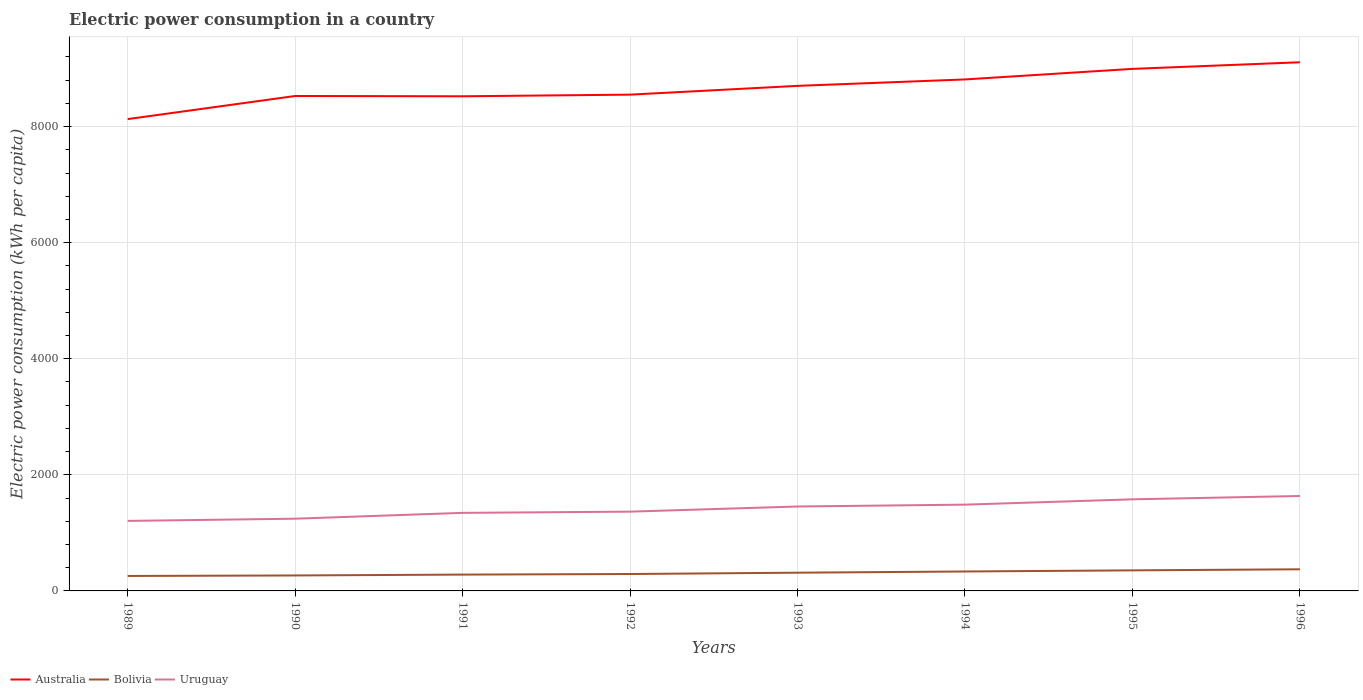How many different coloured lines are there?
Give a very brief answer. 3. Is the number of lines equal to the number of legend labels?
Offer a very short reply. Yes. Across all years, what is the maximum electric power consumption in in Bolivia?
Offer a very short reply. 257.77. In which year was the electric power consumption in in Uruguay maximum?
Offer a very short reply. 1989. What is the total electric power consumption in in Uruguay in the graph?
Your answer should be compact. -391.38. What is the difference between the highest and the second highest electric power consumption in in Bolivia?
Provide a succinct answer. 115.02. What is the difference between the highest and the lowest electric power consumption in in Bolivia?
Provide a succinct answer. 4. How many lines are there?
Your response must be concise. 3. Are the values on the major ticks of Y-axis written in scientific E-notation?
Provide a short and direct response. No. Does the graph contain any zero values?
Offer a very short reply. No. Does the graph contain grids?
Keep it short and to the point. Yes. Where does the legend appear in the graph?
Your answer should be very brief. Bottom left. How many legend labels are there?
Offer a very short reply. 3. How are the legend labels stacked?
Ensure brevity in your answer.  Horizontal. What is the title of the graph?
Your answer should be very brief. Electric power consumption in a country. What is the label or title of the X-axis?
Offer a terse response. Years. What is the label or title of the Y-axis?
Give a very brief answer. Electric power consumption (kWh per capita). What is the Electric power consumption (kWh per capita) in Australia in 1989?
Your answer should be very brief. 8129.1. What is the Electric power consumption (kWh per capita) in Bolivia in 1989?
Offer a terse response. 257.77. What is the Electric power consumption (kWh per capita) in Uruguay in 1989?
Your answer should be compact. 1206.22. What is the Electric power consumption (kWh per capita) of Australia in 1990?
Offer a terse response. 8527.23. What is the Electric power consumption (kWh per capita) of Bolivia in 1990?
Give a very brief answer. 266.47. What is the Electric power consumption (kWh per capita) in Uruguay in 1990?
Your response must be concise. 1244.38. What is the Electric power consumption (kWh per capita) of Australia in 1991?
Your response must be concise. 8522.16. What is the Electric power consumption (kWh per capita) in Bolivia in 1991?
Offer a very short reply. 281.3. What is the Electric power consumption (kWh per capita) in Uruguay in 1991?
Provide a short and direct response. 1344.81. What is the Electric power consumption (kWh per capita) of Australia in 1992?
Ensure brevity in your answer.  8550.33. What is the Electric power consumption (kWh per capita) in Bolivia in 1992?
Offer a terse response. 291.23. What is the Electric power consumption (kWh per capita) in Uruguay in 1992?
Give a very brief answer. 1365.83. What is the Electric power consumption (kWh per capita) in Australia in 1993?
Offer a very short reply. 8701.76. What is the Electric power consumption (kWh per capita) of Bolivia in 1993?
Provide a succinct answer. 314.28. What is the Electric power consumption (kWh per capita) in Uruguay in 1993?
Offer a terse response. 1454.62. What is the Electric power consumption (kWh per capita) of Australia in 1994?
Provide a succinct answer. 8812.49. What is the Electric power consumption (kWh per capita) in Bolivia in 1994?
Ensure brevity in your answer.  334.96. What is the Electric power consumption (kWh per capita) of Uruguay in 1994?
Offer a very short reply. 1486.44. What is the Electric power consumption (kWh per capita) of Australia in 1995?
Ensure brevity in your answer.  8994.36. What is the Electric power consumption (kWh per capita) of Bolivia in 1995?
Provide a succinct answer. 354.18. What is the Electric power consumption (kWh per capita) in Uruguay in 1995?
Offer a very short reply. 1578.08. What is the Electric power consumption (kWh per capita) of Australia in 1996?
Give a very brief answer. 9108.3. What is the Electric power consumption (kWh per capita) in Bolivia in 1996?
Keep it short and to the point. 372.79. What is the Electric power consumption (kWh per capita) in Uruguay in 1996?
Offer a very short reply. 1635.76. Across all years, what is the maximum Electric power consumption (kWh per capita) in Australia?
Provide a short and direct response. 9108.3. Across all years, what is the maximum Electric power consumption (kWh per capita) in Bolivia?
Offer a terse response. 372.79. Across all years, what is the maximum Electric power consumption (kWh per capita) in Uruguay?
Your answer should be compact. 1635.76. Across all years, what is the minimum Electric power consumption (kWh per capita) in Australia?
Offer a terse response. 8129.1. Across all years, what is the minimum Electric power consumption (kWh per capita) of Bolivia?
Your answer should be compact. 257.77. Across all years, what is the minimum Electric power consumption (kWh per capita) in Uruguay?
Your answer should be very brief. 1206.22. What is the total Electric power consumption (kWh per capita) of Australia in the graph?
Offer a very short reply. 6.93e+04. What is the total Electric power consumption (kWh per capita) in Bolivia in the graph?
Make the answer very short. 2472.99. What is the total Electric power consumption (kWh per capita) of Uruguay in the graph?
Provide a short and direct response. 1.13e+04. What is the difference between the Electric power consumption (kWh per capita) of Australia in 1989 and that in 1990?
Keep it short and to the point. -398.12. What is the difference between the Electric power consumption (kWh per capita) of Bolivia in 1989 and that in 1990?
Offer a very short reply. -8.7. What is the difference between the Electric power consumption (kWh per capita) of Uruguay in 1989 and that in 1990?
Offer a very short reply. -38.16. What is the difference between the Electric power consumption (kWh per capita) of Australia in 1989 and that in 1991?
Your response must be concise. -393.06. What is the difference between the Electric power consumption (kWh per capita) in Bolivia in 1989 and that in 1991?
Your answer should be compact. -23.53. What is the difference between the Electric power consumption (kWh per capita) in Uruguay in 1989 and that in 1991?
Make the answer very short. -138.59. What is the difference between the Electric power consumption (kWh per capita) in Australia in 1989 and that in 1992?
Offer a terse response. -421.23. What is the difference between the Electric power consumption (kWh per capita) in Bolivia in 1989 and that in 1992?
Provide a short and direct response. -33.46. What is the difference between the Electric power consumption (kWh per capita) in Uruguay in 1989 and that in 1992?
Offer a terse response. -159.61. What is the difference between the Electric power consumption (kWh per capita) of Australia in 1989 and that in 1993?
Provide a short and direct response. -572.66. What is the difference between the Electric power consumption (kWh per capita) of Bolivia in 1989 and that in 1993?
Your answer should be very brief. -56.51. What is the difference between the Electric power consumption (kWh per capita) in Uruguay in 1989 and that in 1993?
Give a very brief answer. -248.4. What is the difference between the Electric power consumption (kWh per capita) in Australia in 1989 and that in 1994?
Your response must be concise. -683.39. What is the difference between the Electric power consumption (kWh per capita) in Bolivia in 1989 and that in 1994?
Your response must be concise. -77.19. What is the difference between the Electric power consumption (kWh per capita) in Uruguay in 1989 and that in 1994?
Make the answer very short. -280.22. What is the difference between the Electric power consumption (kWh per capita) of Australia in 1989 and that in 1995?
Keep it short and to the point. -865.25. What is the difference between the Electric power consumption (kWh per capita) of Bolivia in 1989 and that in 1995?
Your response must be concise. -96.41. What is the difference between the Electric power consumption (kWh per capita) of Uruguay in 1989 and that in 1995?
Make the answer very short. -371.86. What is the difference between the Electric power consumption (kWh per capita) in Australia in 1989 and that in 1996?
Your answer should be compact. -979.19. What is the difference between the Electric power consumption (kWh per capita) of Bolivia in 1989 and that in 1996?
Give a very brief answer. -115.02. What is the difference between the Electric power consumption (kWh per capita) of Uruguay in 1989 and that in 1996?
Make the answer very short. -429.53. What is the difference between the Electric power consumption (kWh per capita) in Australia in 1990 and that in 1991?
Your answer should be compact. 5.07. What is the difference between the Electric power consumption (kWh per capita) of Bolivia in 1990 and that in 1991?
Offer a very short reply. -14.83. What is the difference between the Electric power consumption (kWh per capita) of Uruguay in 1990 and that in 1991?
Ensure brevity in your answer.  -100.43. What is the difference between the Electric power consumption (kWh per capita) of Australia in 1990 and that in 1992?
Ensure brevity in your answer.  -23.1. What is the difference between the Electric power consumption (kWh per capita) of Bolivia in 1990 and that in 1992?
Offer a terse response. -24.76. What is the difference between the Electric power consumption (kWh per capita) in Uruguay in 1990 and that in 1992?
Offer a very short reply. -121.45. What is the difference between the Electric power consumption (kWh per capita) of Australia in 1990 and that in 1993?
Offer a terse response. -174.53. What is the difference between the Electric power consumption (kWh per capita) of Bolivia in 1990 and that in 1993?
Provide a short and direct response. -47.81. What is the difference between the Electric power consumption (kWh per capita) in Uruguay in 1990 and that in 1993?
Make the answer very short. -210.24. What is the difference between the Electric power consumption (kWh per capita) of Australia in 1990 and that in 1994?
Your answer should be very brief. -285.26. What is the difference between the Electric power consumption (kWh per capita) of Bolivia in 1990 and that in 1994?
Ensure brevity in your answer.  -68.48. What is the difference between the Electric power consumption (kWh per capita) of Uruguay in 1990 and that in 1994?
Make the answer very short. -242.06. What is the difference between the Electric power consumption (kWh per capita) of Australia in 1990 and that in 1995?
Make the answer very short. -467.13. What is the difference between the Electric power consumption (kWh per capita) of Bolivia in 1990 and that in 1995?
Your answer should be compact. -87.71. What is the difference between the Electric power consumption (kWh per capita) in Uruguay in 1990 and that in 1995?
Make the answer very short. -333.7. What is the difference between the Electric power consumption (kWh per capita) of Australia in 1990 and that in 1996?
Offer a very short reply. -581.07. What is the difference between the Electric power consumption (kWh per capita) of Bolivia in 1990 and that in 1996?
Ensure brevity in your answer.  -106.32. What is the difference between the Electric power consumption (kWh per capita) of Uruguay in 1990 and that in 1996?
Give a very brief answer. -391.38. What is the difference between the Electric power consumption (kWh per capita) of Australia in 1991 and that in 1992?
Your answer should be very brief. -28.17. What is the difference between the Electric power consumption (kWh per capita) of Bolivia in 1991 and that in 1992?
Offer a very short reply. -9.93. What is the difference between the Electric power consumption (kWh per capita) of Uruguay in 1991 and that in 1992?
Offer a terse response. -21.03. What is the difference between the Electric power consumption (kWh per capita) in Australia in 1991 and that in 1993?
Your answer should be compact. -179.6. What is the difference between the Electric power consumption (kWh per capita) of Bolivia in 1991 and that in 1993?
Your answer should be compact. -32.98. What is the difference between the Electric power consumption (kWh per capita) of Uruguay in 1991 and that in 1993?
Give a very brief answer. -109.81. What is the difference between the Electric power consumption (kWh per capita) of Australia in 1991 and that in 1994?
Make the answer very short. -290.33. What is the difference between the Electric power consumption (kWh per capita) in Bolivia in 1991 and that in 1994?
Give a very brief answer. -53.66. What is the difference between the Electric power consumption (kWh per capita) in Uruguay in 1991 and that in 1994?
Make the answer very short. -141.64. What is the difference between the Electric power consumption (kWh per capita) of Australia in 1991 and that in 1995?
Keep it short and to the point. -472.2. What is the difference between the Electric power consumption (kWh per capita) of Bolivia in 1991 and that in 1995?
Give a very brief answer. -72.88. What is the difference between the Electric power consumption (kWh per capita) of Uruguay in 1991 and that in 1995?
Keep it short and to the point. -233.27. What is the difference between the Electric power consumption (kWh per capita) in Australia in 1991 and that in 1996?
Give a very brief answer. -586.14. What is the difference between the Electric power consumption (kWh per capita) of Bolivia in 1991 and that in 1996?
Your answer should be compact. -91.49. What is the difference between the Electric power consumption (kWh per capita) of Uruguay in 1991 and that in 1996?
Keep it short and to the point. -290.95. What is the difference between the Electric power consumption (kWh per capita) of Australia in 1992 and that in 1993?
Provide a succinct answer. -151.43. What is the difference between the Electric power consumption (kWh per capita) of Bolivia in 1992 and that in 1993?
Offer a terse response. -23.04. What is the difference between the Electric power consumption (kWh per capita) in Uruguay in 1992 and that in 1993?
Ensure brevity in your answer.  -88.78. What is the difference between the Electric power consumption (kWh per capita) in Australia in 1992 and that in 1994?
Provide a succinct answer. -262.16. What is the difference between the Electric power consumption (kWh per capita) of Bolivia in 1992 and that in 1994?
Your answer should be compact. -43.72. What is the difference between the Electric power consumption (kWh per capita) in Uruguay in 1992 and that in 1994?
Your answer should be very brief. -120.61. What is the difference between the Electric power consumption (kWh per capita) in Australia in 1992 and that in 1995?
Give a very brief answer. -444.03. What is the difference between the Electric power consumption (kWh per capita) in Bolivia in 1992 and that in 1995?
Provide a short and direct response. -62.95. What is the difference between the Electric power consumption (kWh per capita) of Uruguay in 1992 and that in 1995?
Keep it short and to the point. -212.25. What is the difference between the Electric power consumption (kWh per capita) of Australia in 1992 and that in 1996?
Make the answer very short. -557.97. What is the difference between the Electric power consumption (kWh per capita) of Bolivia in 1992 and that in 1996?
Give a very brief answer. -81.56. What is the difference between the Electric power consumption (kWh per capita) of Uruguay in 1992 and that in 1996?
Provide a succinct answer. -269.92. What is the difference between the Electric power consumption (kWh per capita) in Australia in 1993 and that in 1994?
Ensure brevity in your answer.  -110.73. What is the difference between the Electric power consumption (kWh per capita) in Bolivia in 1993 and that in 1994?
Provide a succinct answer. -20.68. What is the difference between the Electric power consumption (kWh per capita) in Uruguay in 1993 and that in 1994?
Offer a terse response. -31.83. What is the difference between the Electric power consumption (kWh per capita) of Australia in 1993 and that in 1995?
Offer a very short reply. -292.6. What is the difference between the Electric power consumption (kWh per capita) in Bolivia in 1993 and that in 1995?
Provide a short and direct response. -39.91. What is the difference between the Electric power consumption (kWh per capita) in Uruguay in 1993 and that in 1995?
Offer a terse response. -123.46. What is the difference between the Electric power consumption (kWh per capita) of Australia in 1993 and that in 1996?
Your response must be concise. -406.54. What is the difference between the Electric power consumption (kWh per capita) in Bolivia in 1993 and that in 1996?
Ensure brevity in your answer.  -58.51. What is the difference between the Electric power consumption (kWh per capita) of Uruguay in 1993 and that in 1996?
Offer a terse response. -181.14. What is the difference between the Electric power consumption (kWh per capita) in Australia in 1994 and that in 1995?
Provide a short and direct response. -181.87. What is the difference between the Electric power consumption (kWh per capita) of Bolivia in 1994 and that in 1995?
Your answer should be very brief. -19.23. What is the difference between the Electric power consumption (kWh per capita) of Uruguay in 1994 and that in 1995?
Give a very brief answer. -91.64. What is the difference between the Electric power consumption (kWh per capita) of Australia in 1994 and that in 1996?
Give a very brief answer. -295.81. What is the difference between the Electric power consumption (kWh per capita) of Bolivia in 1994 and that in 1996?
Provide a succinct answer. -37.83. What is the difference between the Electric power consumption (kWh per capita) of Uruguay in 1994 and that in 1996?
Give a very brief answer. -149.31. What is the difference between the Electric power consumption (kWh per capita) of Australia in 1995 and that in 1996?
Your answer should be compact. -113.94. What is the difference between the Electric power consumption (kWh per capita) of Bolivia in 1995 and that in 1996?
Offer a terse response. -18.61. What is the difference between the Electric power consumption (kWh per capita) in Uruguay in 1995 and that in 1996?
Ensure brevity in your answer.  -57.68. What is the difference between the Electric power consumption (kWh per capita) in Australia in 1989 and the Electric power consumption (kWh per capita) in Bolivia in 1990?
Your response must be concise. 7862.63. What is the difference between the Electric power consumption (kWh per capita) in Australia in 1989 and the Electric power consumption (kWh per capita) in Uruguay in 1990?
Your response must be concise. 6884.73. What is the difference between the Electric power consumption (kWh per capita) in Bolivia in 1989 and the Electric power consumption (kWh per capita) in Uruguay in 1990?
Keep it short and to the point. -986.61. What is the difference between the Electric power consumption (kWh per capita) in Australia in 1989 and the Electric power consumption (kWh per capita) in Bolivia in 1991?
Offer a very short reply. 7847.8. What is the difference between the Electric power consumption (kWh per capita) of Australia in 1989 and the Electric power consumption (kWh per capita) of Uruguay in 1991?
Ensure brevity in your answer.  6784.3. What is the difference between the Electric power consumption (kWh per capita) of Bolivia in 1989 and the Electric power consumption (kWh per capita) of Uruguay in 1991?
Ensure brevity in your answer.  -1087.04. What is the difference between the Electric power consumption (kWh per capita) of Australia in 1989 and the Electric power consumption (kWh per capita) of Bolivia in 1992?
Offer a terse response. 7837.87. What is the difference between the Electric power consumption (kWh per capita) in Australia in 1989 and the Electric power consumption (kWh per capita) in Uruguay in 1992?
Ensure brevity in your answer.  6763.27. What is the difference between the Electric power consumption (kWh per capita) of Bolivia in 1989 and the Electric power consumption (kWh per capita) of Uruguay in 1992?
Ensure brevity in your answer.  -1108.06. What is the difference between the Electric power consumption (kWh per capita) of Australia in 1989 and the Electric power consumption (kWh per capita) of Bolivia in 1993?
Your answer should be very brief. 7814.83. What is the difference between the Electric power consumption (kWh per capita) of Australia in 1989 and the Electric power consumption (kWh per capita) of Uruguay in 1993?
Keep it short and to the point. 6674.49. What is the difference between the Electric power consumption (kWh per capita) of Bolivia in 1989 and the Electric power consumption (kWh per capita) of Uruguay in 1993?
Offer a very short reply. -1196.85. What is the difference between the Electric power consumption (kWh per capita) in Australia in 1989 and the Electric power consumption (kWh per capita) in Bolivia in 1994?
Provide a succinct answer. 7794.15. What is the difference between the Electric power consumption (kWh per capita) of Australia in 1989 and the Electric power consumption (kWh per capita) of Uruguay in 1994?
Provide a succinct answer. 6642.66. What is the difference between the Electric power consumption (kWh per capita) in Bolivia in 1989 and the Electric power consumption (kWh per capita) in Uruguay in 1994?
Your response must be concise. -1228.67. What is the difference between the Electric power consumption (kWh per capita) of Australia in 1989 and the Electric power consumption (kWh per capita) of Bolivia in 1995?
Make the answer very short. 7774.92. What is the difference between the Electric power consumption (kWh per capita) in Australia in 1989 and the Electric power consumption (kWh per capita) in Uruguay in 1995?
Provide a short and direct response. 6551.02. What is the difference between the Electric power consumption (kWh per capita) of Bolivia in 1989 and the Electric power consumption (kWh per capita) of Uruguay in 1995?
Offer a very short reply. -1320.31. What is the difference between the Electric power consumption (kWh per capita) of Australia in 1989 and the Electric power consumption (kWh per capita) of Bolivia in 1996?
Offer a very short reply. 7756.31. What is the difference between the Electric power consumption (kWh per capita) of Australia in 1989 and the Electric power consumption (kWh per capita) of Uruguay in 1996?
Offer a terse response. 6493.35. What is the difference between the Electric power consumption (kWh per capita) of Bolivia in 1989 and the Electric power consumption (kWh per capita) of Uruguay in 1996?
Make the answer very short. -1377.99. What is the difference between the Electric power consumption (kWh per capita) of Australia in 1990 and the Electric power consumption (kWh per capita) of Bolivia in 1991?
Provide a succinct answer. 8245.93. What is the difference between the Electric power consumption (kWh per capita) of Australia in 1990 and the Electric power consumption (kWh per capita) of Uruguay in 1991?
Ensure brevity in your answer.  7182.42. What is the difference between the Electric power consumption (kWh per capita) of Bolivia in 1990 and the Electric power consumption (kWh per capita) of Uruguay in 1991?
Your answer should be very brief. -1078.33. What is the difference between the Electric power consumption (kWh per capita) of Australia in 1990 and the Electric power consumption (kWh per capita) of Bolivia in 1992?
Keep it short and to the point. 8235.99. What is the difference between the Electric power consumption (kWh per capita) of Australia in 1990 and the Electric power consumption (kWh per capita) of Uruguay in 1992?
Provide a short and direct response. 7161.4. What is the difference between the Electric power consumption (kWh per capita) in Bolivia in 1990 and the Electric power consumption (kWh per capita) in Uruguay in 1992?
Provide a succinct answer. -1099.36. What is the difference between the Electric power consumption (kWh per capita) of Australia in 1990 and the Electric power consumption (kWh per capita) of Bolivia in 1993?
Give a very brief answer. 8212.95. What is the difference between the Electric power consumption (kWh per capita) in Australia in 1990 and the Electric power consumption (kWh per capita) in Uruguay in 1993?
Your answer should be compact. 7072.61. What is the difference between the Electric power consumption (kWh per capita) in Bolivia in 1990 and the Electric power consumption (kWh per capita) in Uruguay in 1993?
Your answer should be compact. -1188.14. What is the difference between the Electric power consumption (kWh per capita) in Australia in 1990 and the Electric power consumption (kWh per capita) in Bolivia in 1994?
Your answer should be compact. 8192.27. What is the difference between the Electric power consumption (kWh per capita) in Australia in 1990 and the Electric power consumption (kWh per capita) in Uruguay in 1994?
Ensure brevity in your answer.  7040.79. What is the difference between the Electric power consumption (kWh per capita) in Bolivia in 1990 and the Electric power consumption (kWh per capita) in Uruguay in 1994?
Your response must be concise. -1219.97. What is the difference between the Electric power consumption (kWh per capita) in Australia in 1990 and the Electric power consumption (kWh per capita) in Bolivia in 1995?
Your answer should be compact. 8173.05. What is the difference between the Electric power consumption (kWh per capita) of Australia in 1990 and the Electric power consumption (kWh per capita) of Uruguay in 1995?
Keep it short and to the point. 6949.15. What is the difference between the Electric power consumption (kWh per capita) of Bolivia in 1990 and the Electric power consumption (kWh per capita) of Uruguay in 1995?
Give a very brief answer. -1311.61. What is the difference between the Electric power consumption (kWh per capita) of Australia in 1990 and the Electric power consumption (kWh per capita) of Bolivia in 1996?
Your answer should be compact. 8154.44. What is the difference between the Electric power consumption (kWh per capita) in Australia in 1990 and the Electric power consumption (kWh per capita) in Uruguay in 1996?
Your answer should be very brief. 6891.47. What is the difference between the Electric power consumption (kWh per capita) of Bolivia in 1990 and the Electric power consumption (kWh per capita) of Uruguay in 1996?
Offer a very short reply. -1369.28. What is the difference between the Electric power consumption (kWh per capita) of Australia in 1991 and the Electric power consumption (kWh per capita) of Bolivia in 1992?
Your answer should be compact. 8230.92. What is the difference between the Electric power consumption (kWh per capita) in Australia in 1991 and the Electric power consumption (kWh per capita) in Uruguay in 1992?
Keep it short and to the point. 7156.33. What is the difference between the Electric power consumption (kWh per capita) of Bolivia in 1991 and the Electric power consumption (kWh per capita) of Uruguay in 1992?
Ensure brevity in your answer.  -1084.53. What is the difference between the Electric power consumption (kWh per capita) of Australia in 1991 and the Electric power consumption (kWh per capita) of Bolivia in 1993?
Offer a very short reply. 8207.88. What is the difference between the Electric power consumption (kWh per capita) in Australia in 1991 and the Electric power consumption (kWh per capita) in Uruguay in 1993?
Provide a short and direct response. 7067.54. What is the difference between the Electric power consumption (kWh per capita) of Bolivia in 1991 and the Electric power consumption (kWh per capita) of Uruguay in 1993?
Offer a terse response. -1173.32. What is the difference between the Electric power consumption (kWh per capita) of Australia in 1991 and the Electric power consumption (kWh per capita) of Bolivia in 1994?
Give a very brief answer. 8187.2. What is the difference between the Electric power consumption (kWh per capita) of Australia in 1991 and the Electric power consumption (kWh per capita) of Uruguay in 1994?
Offer a terse response. 7035.72. What is the difference between the Electric power consumption (kWh per capita) in Bolivia in 1991 and the Electric power consumption (kWh per capita) in Uruguay in 1994?
Make the answer very short. -1205.14. What is the difference between the Electric power consumption (kWh per capita) of Australia in 1991 and the Electric power consumption (kWh per capita) of Bolivia in 1995?
Give a very brief answer. 8167.98. What is the difference between the Electric power consumption (kWh per capita) in Australia in 1991 and the Electric power consumption (kWh per capita) in Uruguay in 1995?
Provide a short and direct response. 6944.08. What is the difference between the Electric power consumption (kWh per capita) in Bolivia in 1991 and the Electric power consumption (kWh per capita) in Uruguay in 1995?
Your answer should be compact. -1296.78. What is the difference between the Electric power consumption (kWh per capita) in Australia in 1991 and the Electric power consumption (kWh per capita) in Bolivia in 1996?
Keep it short and to the point. 8149.37. What is the difference between the Electric power consumption (kWh per capita) in Australia in 1991 and the Electric power consumption (kWh per capita) in Uruguay in 1996?
Your answer should be very brief. 6886.4. What is the difference between the Electric power consumption (kWh per capita) in Bolivia in 1991 and the Electric power consumption (kWh per capita) in Uruguay in 1996?
Offer a very short reply. -1354.46. What is the difference between the Electric power consumption (kWh per capita) of Australia in 1992 and the Electric power consumption (kWh per capita) of Bolivia in 1993?
Provide a succinct answer. 8236.05. What is the difference between the Electric power consumption (kWh per capita) of Australia in 1992 and the Electric power consumption (kWh per capita) of Uruguay in 1993?
Your response must be concise. 7095.71. What is the difference between the Electric power consumption (kWh per capita) in Bolivia in 1992 and the Electric power consumption (kWh per capita) in Uruguay in 1993?
Your response must be concise. -1163.38. What is the difference between the Electric power consumption (kWh per capita) in Australia in 1992 and the Electric power consumption (kWh per capita) in Bolivia in 1994?
Your response must be concise. 8215.37. What is the difference between the Electric power consumption (kWh per capita) in Australia in 1992 and the Electric power consumption (kWh per capita) in Uruguay in 1994?
Your response must be concise. 7063.89. What is the difference between the Electric power consumption (kWh per capita) in Bolivia in 1992 and the Electric power consumption (kWh per capita) in Uruguay in 1994?
Your answer should be compact. -1195.21. What is the difference between the Electric power consumption (kWh per capita) of Australia in 1992 and the Electric power consumption (kWh per capita) of Bolivia in 1995?
Offer a terse response. 8196.15. What is the difference between the Electric power consumption (kWh per capita) in Australia in 1992 and the Electric power consumption (kWh per capita) in Uruguay in 1995?
Your answer should be compact. 6972.25. What is the difference between the Electric power consumption (kWh per capita) of Bolivia in 1992 and the Electric power consumption (kWh per capita) of Uruguay in 1995?
Offer a very short reply. -1286.84. What is the difference between the Electric power consumption (kWh per capita) of Australia in 1992 and the Electric power consumption (kWh per capita) of Bolivia in 1996?
Your response must be concise. 8177.54. What is the difference between the Electric power consumption (kWh per capita) in Australia in 1992 and the Electric power consumption (kWh per capita) in Uruguay in 1996?
Ensure brevity in your answer.  6914.57. What is the difference between the Electric power consumption (kWh per capita) of Bolivia in 1992 and the Electric power consumption (kWh per capita) of Uruguay in 1996?
Keep it short and to the point. -1344.52. What is the difference between the Electric power consumption (kWh per capita) in Australia in 1993 and the Electric power consumption (kWh per capita) in Bolivia in 1994?
Offer a very short reply. 8366.8. What is the difference between the Electric power consumption (kWh per capita) of Australia in 1993 and the Electric power consumption (kWh per capita) of Uruguay in 1994?
Ensure brevity in your answer.  7215.32. What is the difference between the Electric power consumption (kWh per capita) in Bolivia in 1993 and the Electric power consumption (kWh per capita) in Uruguay in 1994?
Provide a short and direct response. -1172.16. What is the difference between the Electric power consumption (kWh per capita) in Australia in 1993 and the Electric power consumption (kWh per capita) in Bolivia in 1995?
Your answer should be very brief. 8347.58. What is the difference between the Electric power consumption (kWh per capita) of Australia in 1993 and the Electric power consumption (kWh per capita) of Uruguay in 1995?
Provide a short and direct response. 7123.68. What is the difference between the Electric power consumption (kWh per capita) in Bolivia in 1993 and the Electric power consumption (kWh per capita) in Uruguay in 1995?
Your response must be concise. -1263.8. What is the difference between the Electric power consumption (kWh per capita) in Australia in 1993 and the Electric power consumption (kWh per capita) in Bolivia in 1996?
Your response must be concise. 8328.97. What is the difference between the Electric power consumption (kWh per capita) of Australia in 1993 and the Electric power consumption (kWh per capita) of Uruguay in 1996?
Your response must be concise. 7066. What is the difference between the Electric power consumption (kWh per capita) of Bolivia in 1993 and the Electric power consumption (kWh per capita) of Uruguay in 1996?
Give a very brief answer. -1321.48. What is the difference between the Electric power consumption (kWh per capita) of Australia in 1994 and the Electric power consumption (kWh per capita) of Bolivia in 1995?
Provide a short and direct response. 8458.31. What is the difference between the Electric power consumption (kWh per capita) of Australia in 1994 and the Electric power consumption (kWh per capita) of Uruguay in 1995?
Provide a short and direct response. 7234.41. What is the difference between the Electric power consumption (kWh per capita) in Bolivia in 1994 and the Electric power consumption (kWh per capita) in Uruguay in 1995?
Offer a very short reply. -1243.12. What is the difference between the Electric power consumption (kWh per capita) in Australia in 1994 and the Electric power consumption (kWh per capita) in Bolivia in 1996?
Offer a terse response. 8439.7. What is the difference between the Electric power consumption (kWh per capita) of Australia in 1994 and the Electric power consumption (kWh per capita) of Uruguay in 1996?
Make the answer very short. 7176.73. What is the difference between the Electric power consumption (kWh per capita) of Bolivia in 1994 and the Electric power consumption (kWh per capita) of Uruguay in 1996?
Provide a succinct answer. -1300.8. What is the difference between the Electric power consumption (kWh per capita) of Australia in 1995 and the Electric power consumption (kWh per capita) of Bolivia in 1996?
Your answer should be very brief. 8621.56. What is the difference between the Electric power consumption (kWh per capita) in Australia in 1995 and the Electric power consumption (kWh per capita) in Uruguay in 1996?
Your answer should be very brief. 7358.6. What is the difference between the Electric power consumption (kWh per capita) of Bolivia in 1995 and the Electric power consumption (kWh per capita) of Uruguay in 1996?
Your answer should be compact. -1281.57. What is the average Electric power consumption (kWh per capita) of Australia per year?
Offer a very short reply. 8668.22. What is the average Electric power consumption (kWh per capita) of Bolivia per year?
Give a very brief answer. 309.12. What is the average Electric power consumption (kWh per capita) of Uruguay per year?
Offer a terse response. 1414.52. In the year 1989, what is the difference between the Electric power consumption (kWh per capita) in Australia and Electric power consumption (kWh per capita) in Bolivia?
Your answer should be very brief. 7871.33. In the year 1989, what is the difference between the Electric power consumption (kWh per capita) in Australia and Electric power consumption (kWh per capita) in Uruguay?
Your answer should be compact. 6922.88. In the year 1989, what is the difference between the Electric power consumption (kWh per capita) of Bolivia and Electric power consumption (kWh per capita) of Uruguay?
Provide a short and direct response. -948.45. In the year 1990, what is the difference between the Electric power consumption (kWh per capita) of Australia and Electric power consumption (kWh per capita) of Bolivia?
Provide a succinct answer. 8260.76. In the year 1990, what is the difference between the Electric power consumption (kWh per capita) in Australia and Electric power consumption (kWh per capita) in Uruguay?
Make the answer very short. 7282.85. In the year 1990, what is the difference between the Electric power consumption (kWh per capita) in Bolivia and Electric power consumption (kWh per capita) in Uruguay?
Your answer should be very brief. -977.91. In the year 1991, what is the difference between the Electric power consumption (kWh per capita) of Australia and Electric power consumption (kWh per capita) of Bolivia?
Your answer should be compact. 8240.86. In the year 1991, what is the difference between the Electric power consumption (kWh per capita) in Australia and Electric power consumption (kWh per capita) in Uruguay?
Offer a very short reply. 7177.35. In the year 1991, what is the difference between the Electric power consumption (kWh per capita) in Bolivia and Electric power consumption (kWh per capita) in Uruguay?
Your response must be concise. -1063.51. In the year 1992, what is the difference between the Electric power consumption (kWh per capita) in Australia and Electric power consumption (kWh per capita) in Bolivia?
Provide a succinct answer. 8259.09. In the year 1992, what is the difference between the Electric power consumption (kWh per capita) in Australia and Electric power consumption (kWh per capita) in Uruguay?
Provide a short and direct response. 7184.5. In the year 1992, what is the difference between the Electric power consumption (kWh per capita) of Bolivia and Electric power consumption (kWh per capita) of Uruguay?
Your answer should be very brief. -1074.6. In the year 1993, what is the difference between the Electric power consumption (kWh per capita) of Australia and Electric power consumption (kWh per capita) of Bolivia?
Offer a very short reply. 8387.48. In the year 1993, what is the difference between the Electric power consumption (kWh per capita) in Australia and Electric power consumption (kWh per capita) in Uruguay?
Your response must be concise. 7247.14. In the year 1993, what is the difference between the Electric power consumption (kWh per capita) in Bolivia and Electric power consumption (kWh per capita) in Uruguay?
Your response must be concise. -1140.34. In the year 1994, what is the difference between the Electric power consumption (kWh per capita) of Australia and Electric power consumption (kWh per capita) of Bolivia?
Keep it short and to the point. 8477.53. In the year 1994, what is the difference between the Electric power consumption (kWh per capita) of Australia and Electric power consumption (kWh per capita) of Uruguay?
Offer a very short reply. 7326.05. In the year 1994, what is the difference between the Electric power consumption (kWh per capita) in Bolivia and Electric power consumption (kWh per capita) in Uruguay?
Offer a very short reply. -1151.49. In the year 1995, what is the difference between the Electric power consumption (kWh per capita) of Australia and Electric power consumption (kWh per capita) of Bolivia?
Offer a terse response. 8640.17. In the year 1995, what is the difference between the Electric power consumption (kWh per capita) of Australia and Electric power consumption (kWh per capita) of Uruguay?
Your response must be concise. 7416.28. In the year 1995, what is the difference between the Electric power consumption (kWh per capita) in Bolivia and Electric power consumption (kWh per capita) in Uruguay?
Your answer should be compact. -1223.9. In the year 1996, what is the difference between the Electric power consumption (kWh per capita) in Australia and Electric power consumption (kWh per capita) in Bolivia?
Your answer should be compact. 8735.5. In the year 1996, what is the difference between the Electric power consumption (kWh per capita) in Australia and Electric power consumption (kWh per capita) in Uruguay?
Your answer should be very brief. 7472.54. In the year 1996, what is the difference between the Electric power consumption (kWh per capita) of Bolivia and Electric power consumption (kWh per capita) of Uruguay?
Offer a very short reply. -1262.96. What is the ratio of the Electric power consumption (kWh per capita) in Australia in 1989 to that in 1990?
Give a very brief answer. 0.95. What is the ratio of the Electric power consumption (kWh per capita) of Bolivia in 1989 to that in 1990?
Provide a short and direct response. 0.97. What is the ratio of the Electric power consumption (kWh per capita) in Uruguay in 1989 to that in 1990?
Offer a very short reply. 0.97. What is the ratio of the Electric power consumption (kWh per capita) of Australia in 1989 to that in 1991?
Keep it short and to the point. 0.95. What is the ratio of the Electric power consumption (kWh per capita) of Bolivia in 1989 to that in 1991?
Keep it short and to the point. 0.92. What is the ratio of the Electric power consumption (kWh per capita) of Uruguay in 1989 to that in 1991?
Your response must be concise. 0.9. What is the ratio of the Electric power consumption (kWh per capita) in Australia in 1989 to that in 1992?
Your answer should be very brief. 0.95. What is the ratio of the Electric power consumption (kWh per capita) of Bolivia in 1989 to that in 1992?
Your answer should be very brief. 0.89. What is the ratio of the Electric power consumption (kWh per capita) of Uruguay in 1989 to that in 1992?
Offer a terse response. 0.88. What is the ratio of the Electric power consumption (kWh per capita) in Australia in 1989 to that in 1993?
Ensure brevity in your answer.  0.93. What is the ratio of the Electric power consumption (kWh per capita) of Bolivia in 1989 to that in 1993?
Keep it short and to the point. 0.82. What is the ratio of the Electric power consumption (kWh per capita) of Uruguay in 1989 to that in 1993?
Your answer should be very brief. 0.83. What is the ratio of the Electric power consumption (kWh per capita) in Australia in 1989 to that in 1994?
Provide a short and direct response. 0.92. What is the ratio of the Electric power consumption (kWh per capita) in Bolivia in 1989 to that in 1994?
Ensure brevity in your answer.  0.77. What is the ratio of the Electric power consumption (kWh per capita) of Uruguay in 1989 to that in 1994?
Keep it short and to the point. 0.81. What is the ratio of the Electric power consumption (kWh per capita) in Australia in 1989 to that in 1995?
Make the answer very short. 0.9. What is the ratio of the Electric power consumption (kWh per capita) in Bolivia in 1989 to that in 1995?
Ensure brevity in your answer.  0.73. What is the ratio of the Electric power consumption (kWh per capita) in Uruguay in 1989 to that in 1995?
Provide a succinct answer. 0.76. What is the ratio of the Electric power consumption (kWh per capita) of Australia in 1989 to that in 1996?
Keep it short and to the point. 0.89. What is the ratio of the Electric power consumption (kWh per capita) in Bolivia in 1989 to that in 1996?
Provide a succinct answer. 0.69. What is the ratio of the Electric power consumption (kWh per capita) of Uruguay in 1989 to that in 1996?
Make the answer very short. 0.74. What is the ratio of the Electric power consumption (kWh per capita) in Australia in 1990 to that in 1991?
Offer a very short reply. 1. What is the ratio of the Electric power consumption (kWh per capita) of Bolivia in 1990 to that in 1991?
Keep it short and to the point. 0.95. What is the ratio of the Electric power consumption (kWh per capita) in Uruguay in 1990 to that in 1991?
Provide a short and direct response. 0.93. What is the ratio of the Electric power consumption (kWh per capita) of Australia in 1990 to that in 1992?
Your response must be concise. 1. What is the ratio of the Electric power consumption (kWh per capita) in Bolivia in 1990 to that in 1992?
Provide a short and direct response. 0.92. What is the ratio of the Electric power consumption (kWh per capita) in Uruguay in 1990 to that in 1992?
Your answer should be very brief. 0.91. What is the ratio of the Electric power consumption (kWh per capita) in Australia in 1990 to that in 1993?
Provide a short and direct response. 0.98. What is the ratio of the Electric power consumption (kWh per capita) in Bolivia in 1990 to that in 1993?
Your response must be concise. 0.85. What is the ratio of the Electric power consumption (kWh per capita) in Uruguay in 1990 to that in 1993?
Provide a succinct answer. 0.86. What is the ratio of the Electric power consumption (kWh per capita) of Australia in 1990 to that in 1994?
Your answer should be very brief. 0.97. What is the ratio of the Electric power consumption (kWh per capita) in Bolivia in 1990 to that in 1994?
Provide a succinct answer. 0.8. What is the ratio of the Electric power consumption (kWh per capita) of Uruguay in 1990 to that in 1994?
Provide a succinct answer. 0.84. What is the ratio of the Electric power consumption (kWh per capita) in Australia in 1990 to that in 1995?
Keep it short and to the point. 0.95. What is the ratio of the Electric power consumption (kWh per capita) of Bolivia in 1990 to that in 1995?
Provide a succinct answer. 0.75. What is the ratio of the Electric power consumption (kWh per capita) in Uruguay in 1990 to that in 1995?
Give a very brief answer. 0.79. What is the ratio of the Electric power consumption (kWh per capita) of Australia in 1990 to that in 1996?
Your answer should be very brief. 0.94. What is the ratio of the Electric power consumption (kWh per capita) in Bolivia in 1990 to that in 1996?
Keep it short and to the point. 0.71. What is the ratio of the Electric power consumption (kWh per capita) in Uruguay in 1990 to that in 1996?
Your answer should be compact. 0.76. What is the ratio of the Electric power consumption (kWh per capita) in Bolivia in 1991 to that in 1992?
Give a very brief answer. 0.97. What is the ratio of the Electric power consumption (kWh per capita) of Uruguay in 1991 to that in 1992?
Offer a very short reply. 0.98. What is the ratio of the Electric power consumption (kWh per capita) in Australia in 1991 to that in 1993?
Provide a short and direct response. 0.98. What is the ratio of the Electric power consumption (kWh per capita) of Bolivia in 1991 to that in 1993?
Make the answer very short. 0.9. What is the ratio of the Electric power consumption (kWh per capita) in Uruguay in 1991 to that in 1993?
Offer a terse response. 0.92. What is the ratio of the Electric power consumption (kWh per capita) in Australia in 1991 to that in 1994?
Offer a very short reply. 0.97. What is the ratio of the Electric power consumption (kWh per capita) of Bolivia in 1991 to that in 1994?
Your response must be concise. 0.84. What is the ratio of the Electric power consumption (kWh per capita) of Uruguay in 1991 to that in 1994?
Make the answer very short. 0.9. What is the ratio of the Electric power consumption (kWh per capita) of Australia in 1991 to that in 1995?
Offer a very short reply. 0.95. What is the ratio of the Electric power consumption (kWh per capita) in Bolivia in 1991 to that in 1995?
Your response must be concise. 0.79. What is the ratio of the Electric power consumption (kWh per capita) of Uruguay in 1991 to that in 1995?
Your answer should be very brief. 0.85. What is the ratio of the Electric power consumption (kWh per capita) in Australia in 1991 to that in 1996?
Make the answer very short. 0.94. What is the ratio of the Electric power consumption (kWh per capita) in Bolivia in 1991 to that in 1996?
Provide a succinct answer. 0.75. What is the ratio of the Electric power consumption (kWh per capita) in Uruguay in 1991 to that in 1996?
Offer a terse response. 0.82. What is the ratio of the Electric power consumption (kWh per capita) of Australia in 1992 to that in 1993?
Your response must be concise. 0.98. What is the ratio of the Electric power consumption (kWh per capita) of Bolivia in 1992 to that in 1993?
Offer a terse response. 0.93. What is the ratio of the Electric power consumption (kWh per capita) of Uruguay in 1992 to that in 1993?
Offer a very short reply. 0.94. What is the ratio of the Electric power consumption (kWh per capita) of Australia in 1992 to that in 1994?
Your answer should be compact. 0.97. What is the ratio of the Electric power consumption (kWh per capita) in Bolivia in 1992 to that in 1994?
Your answer should be very brief. 0.87. What is the ratio of the Electric power consumption (kWh per capita) of Uruguay in 1992 to that in 1994?
Offer a terse response. 0.92. What is the ratio of the Electric power consumption (kWh per capita) of Australia in 1992 to that in 1995?
Offer a terse response. 0.95. What is the ratio of the Electric power consumption (kWh per capita) in Bolivia in 1992 to that in 1995?
Give a very brief answer. 0.82. What is the ratio of the Electric power consumption (kWh per capita) of Uruguay in 1992 to that in 1995?
Provide a short and direct response. 0.87. What is the ratio of the Electric power consumption (kWh per capita) of Australia in 1992 to that in 1996?
Your answer should be very brief. 0.94. What is the ratio of the Electric power consumption (kWh per capita) in Bolivia in 1992 to that in 1996?
Give a very brief answer. 0.78. What is the ratio of the Electric power consumption (kWh per capita) of Uruguay in 1992 to that in 1996?
Give a very brief answer. 0.83. What is the ratio of the Electric power consumption (kWh per capita) in Australia in 1993 to that in 1994?
Give a very brief answer. 0.99. What is the ratio of the Electric power consumption (kWh per capita) in Bolivia in 1993 to that in 1994?
Make the answer very short. 0.94. What is the ratio of the Electric power consumption (kWh per capita) in Uruguay in 1993 to that in 1994?
Your response must be concise. 0.98. What is the ratio of the Electric power consumption (kWh per capita) of Australia in 1993 to that in 1995?
Offer a terse response. 0.97. What is the ratio of the Electric power consumption (kWh per capita) in Bolivia in 1993 to that in 1995?
Offer a terse response. 0.89. What is the ratio of the Electric power consumption (kWh per capita) of Uruguay in 1993 to that in 1995?
Offer a terse response. 0.92. What is the ratio of the Electric power consumption (kWh per capita) in Australia in 1993 to that in 1996?
Your answer should be compact. 0.96. What is the ratio of the Electric power consumption (kWh per capita) of Bolivia in 1993 to that in 1996?
Give a very brief answer. 0.84. What is the ratio of the Electric power consumption (kWh per capita) of Uruguay in 1993 to that in 1996?
Provide a short and direct response. 0.89. What is the ratio of the Electric power consumption (kWh per capita) in Australia in 1994 to that in 1995?
Provide a succinct answer. 0.98. What is the ratio of the Electric power consumption (kWh per capita) of Bolivia in 1994 to that in 1995?
Give a very brief answer. 0.95. What is the ratio of the Electric power consumption (kWh per capita) of Uruguay in 1994 to that in 1995?
Your answer should be very brief. 0.94. What is the ratio of the Electric power consumption (kWh per capita) of Australia in 1994 to that in 1996?
Provide a succinct answer. 0.97. What is the ratio of the Electric power consumption (kWh per capita) in Bolivia in 1994 to that in 1996?
Your answer should be compact. 0.9. What is the ratio of the Electric power consumption (kWh per capita) of Uruguay in 1994 to that in 1996?
Keep it short and to the point. 0.91. What is the ratio of the Electric power consumption (kWh per capita) of Australia in 1995 to that in 1996?
Give a very brief answer. 0.99. What is the ratio of the Electric power consumption (kWh per capita) in Bolivia in 1995 to that in 1996?
Provide a succinct answer. 0.95. What is the ratio of the Electric power consumption (kWh per capita) of Uruguay in 1995 to that in 1996?
Your answer should be compact. 0.96. What is the difference between the highest and the second highest Electric power consumption (kWh per capita) of Australia?
Make the answer very short. 113.94. What is the difference between the highest and the second highest Electric power consumption (kWh per capita) of Bolivia?
Your response must be concise. 18.61. What is the difference between the highest and the second highest Electric power consumption (kWh per capita) of Uruguay?
Keep it short and to the point. 57.68. What is the difference between the highest and the lowest Electric power consumption (kWh per capita) of Australia?
Your response must be concise. 979.19. What is the difference between the highest and the lowest Electric power consumption (kWh per capita) in Bolivia?
Offer a very short reply. 115.02. What is the difference between the highest and the lowest Electric power consumption (kWh per capita) in Uruguay?
Your response must be concise. 429.53. 